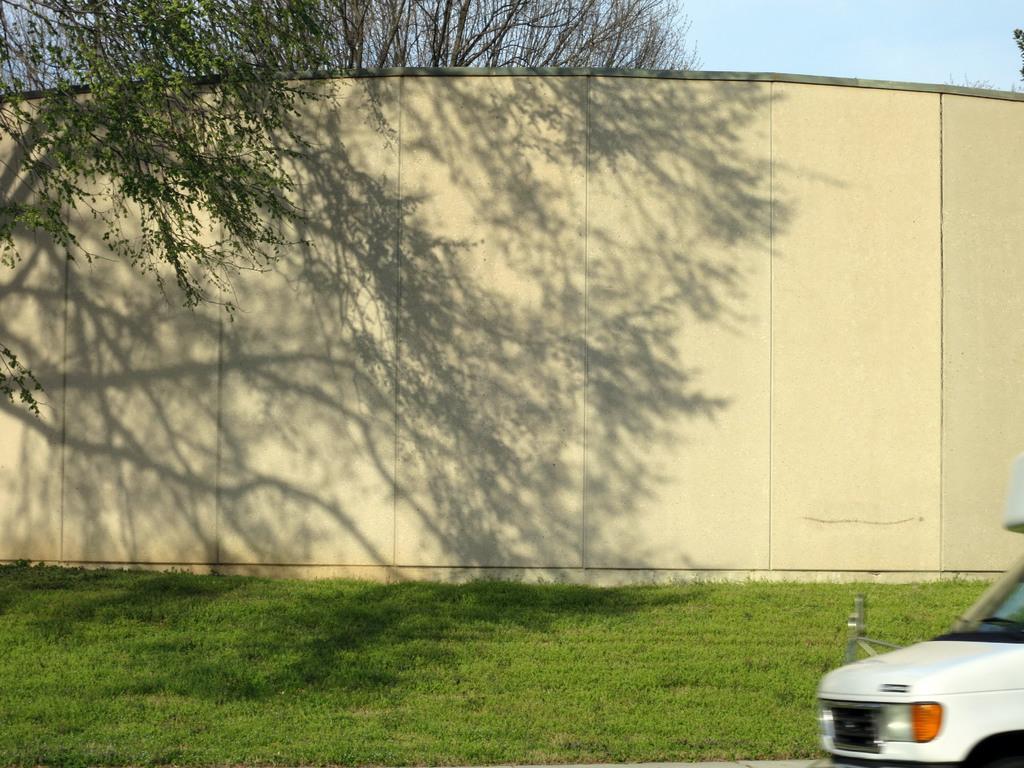Please provide a concise description of this image. This image is taken outdoors. At the bottom of the image there is a ground with grass on it. At the top of the image there is a sky. In the background there is a wall and there are a few trees. On the right side of the image there is a vehicle. 